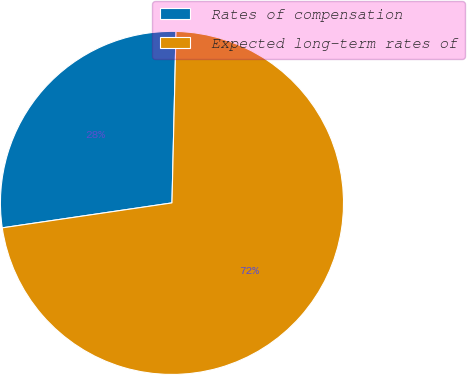Convert chart. <chart><loc_0><loc_0><loc_500><loc_500><pie_chart><fcel>Rates of compensation<fcel>Expected long-term rates of<nl><fcel>27.7%<fcel>72.3%<nl></chart> 